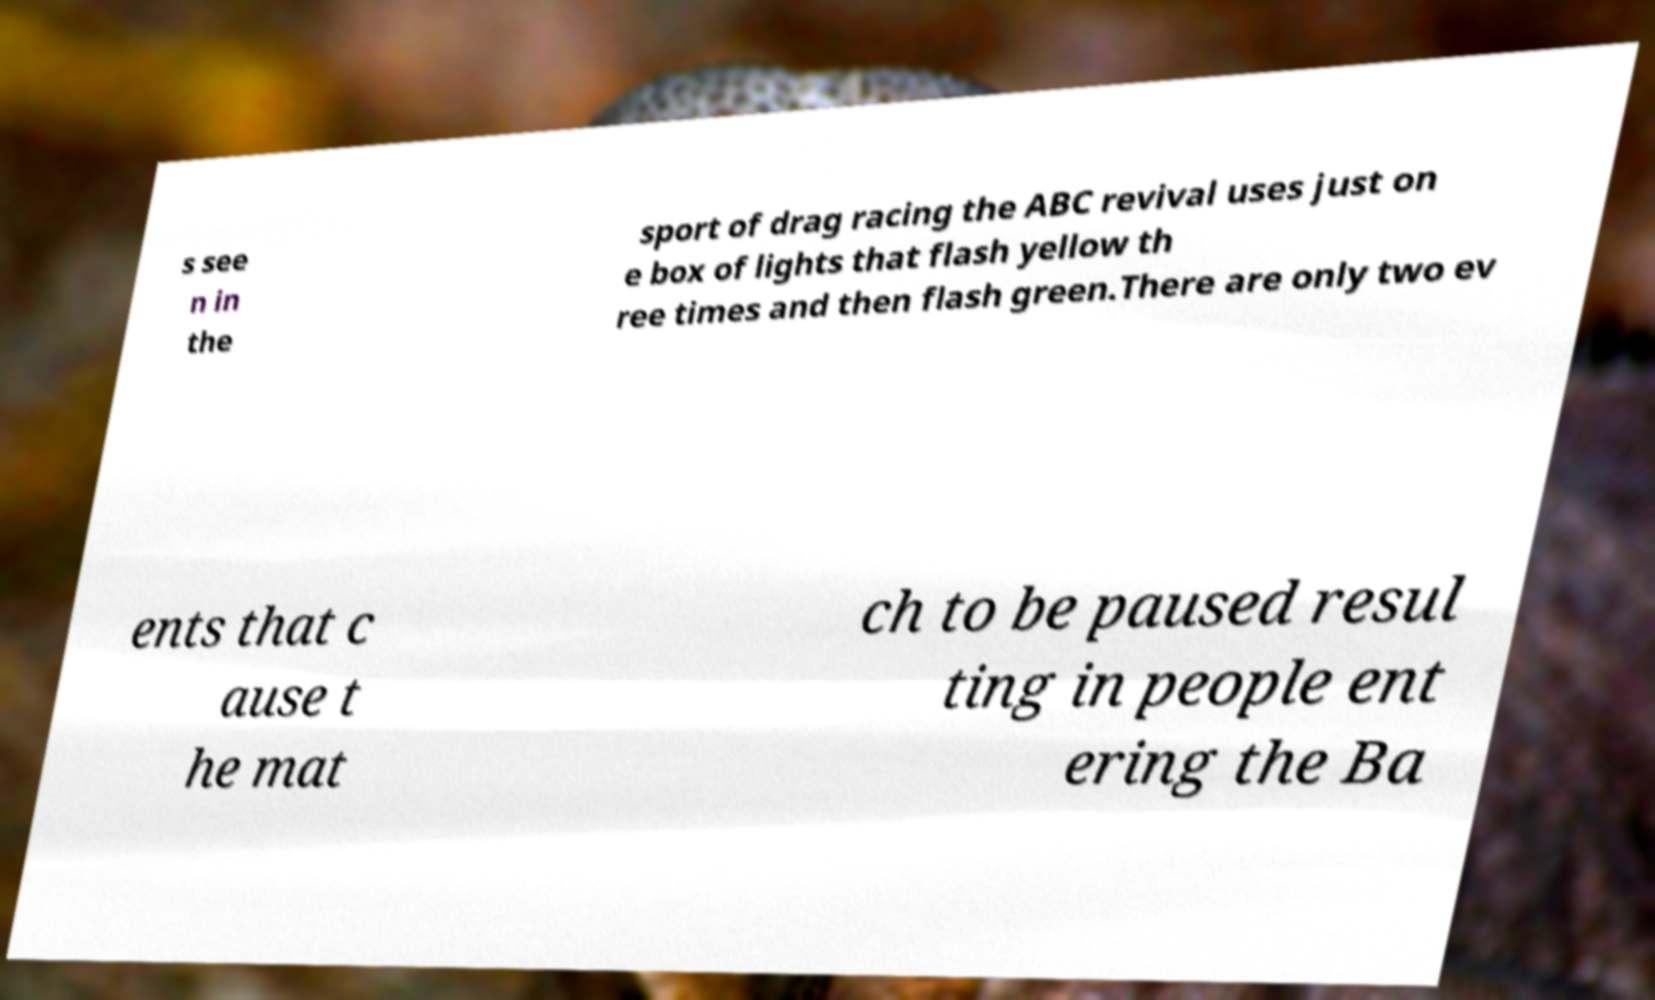For documentation purposes, I need the text within this image transcribed. Could you provide that? s see n in the sport of drag racing the ABC revival uses just on e box of lights that flash yellow th ree times and then flash green.There are only two ev ents that c ause t he mat ch to be paused resul ting in people ent ering the Ba 